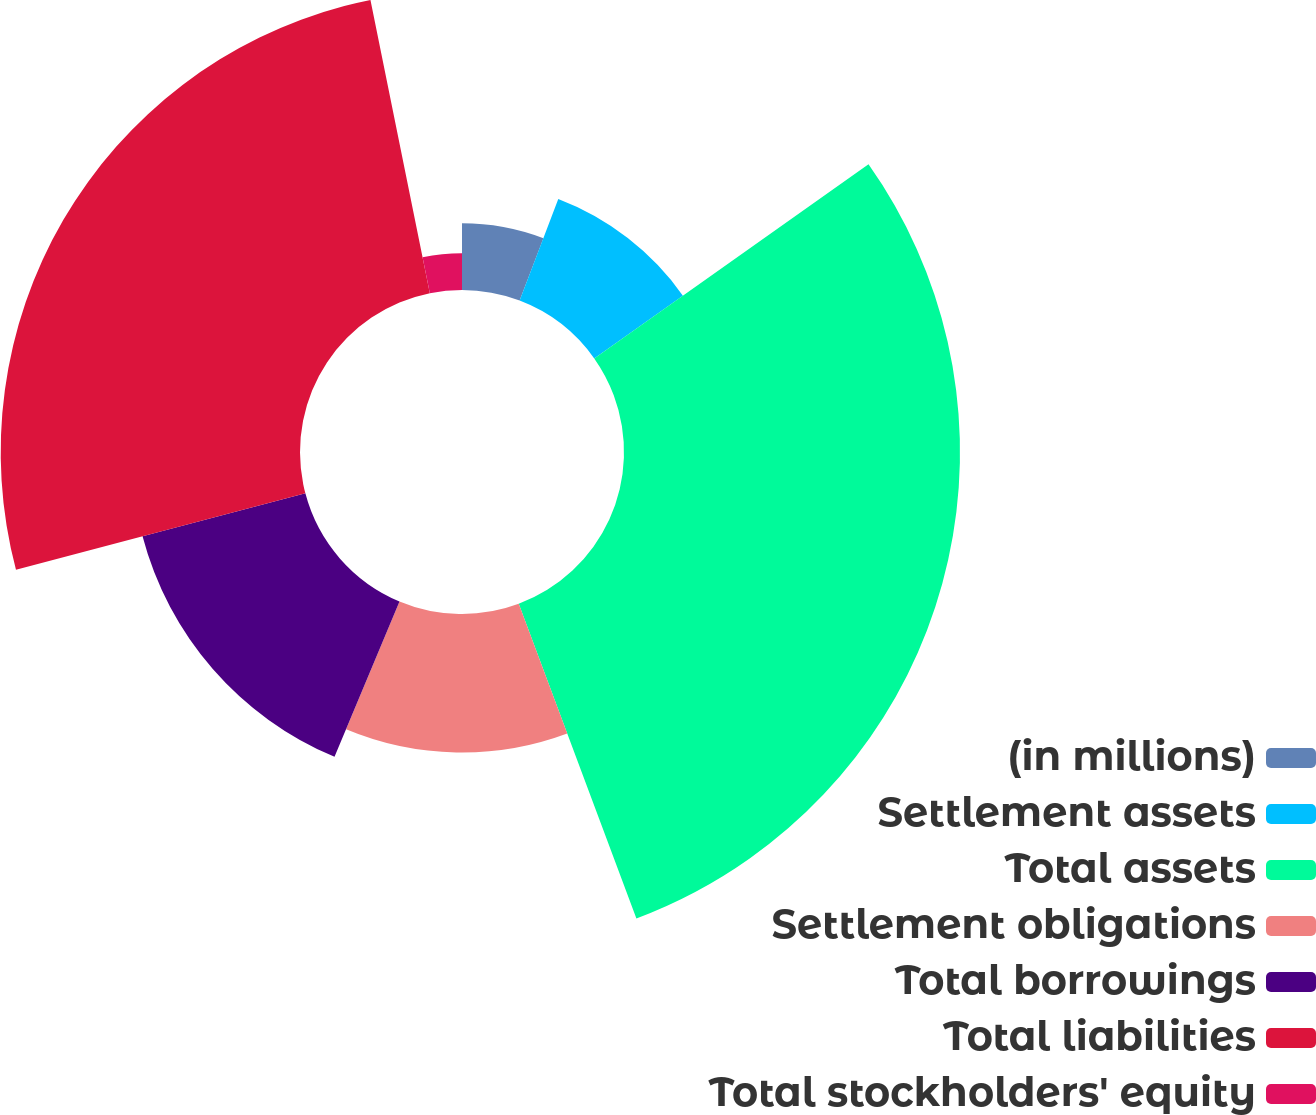<chart> <loc_0><loc_0><loc_500><loc_500><pie_chart><fcel>(in millions)<fcel>Settlement assets<fcel>Total assets<fcel>Settlement obligations<fcel>Total borrowings<fcel>Total liabilities<fcel>Total stockholders' equity<nl><fcel>5.79%<fcel>9.41%<fcel>29.11%<fcel>12.0%<fcel>14.59%<fcel>25.93%<fcel>3.18%<nl></chart> 